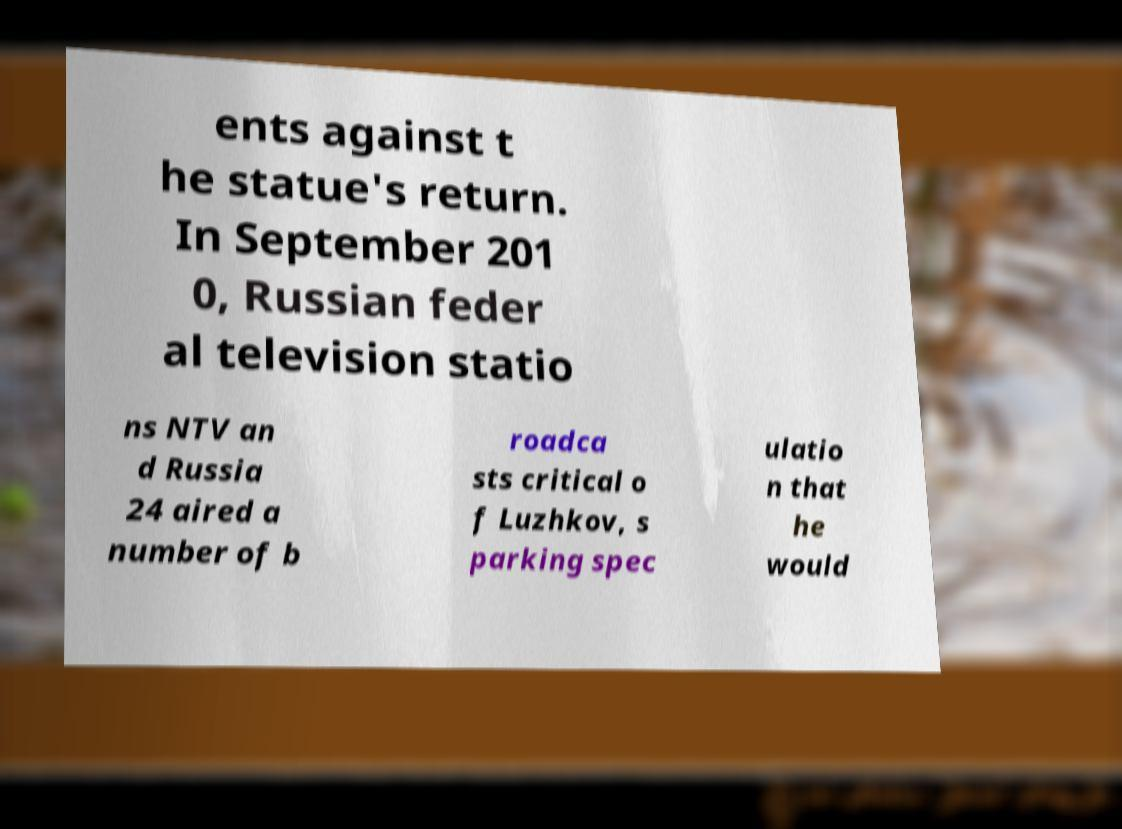Can you read and provide the text displayed in the image?This photo seems to have some interesting text. Can you extract and type it out for me? ents against t he statue's return. In September 201 0, Russian feder al television statio ns NTV an d Russia 24 aired a number of b roadca sts critical o f Luzhkov, s parking spec ulatio n that he would 